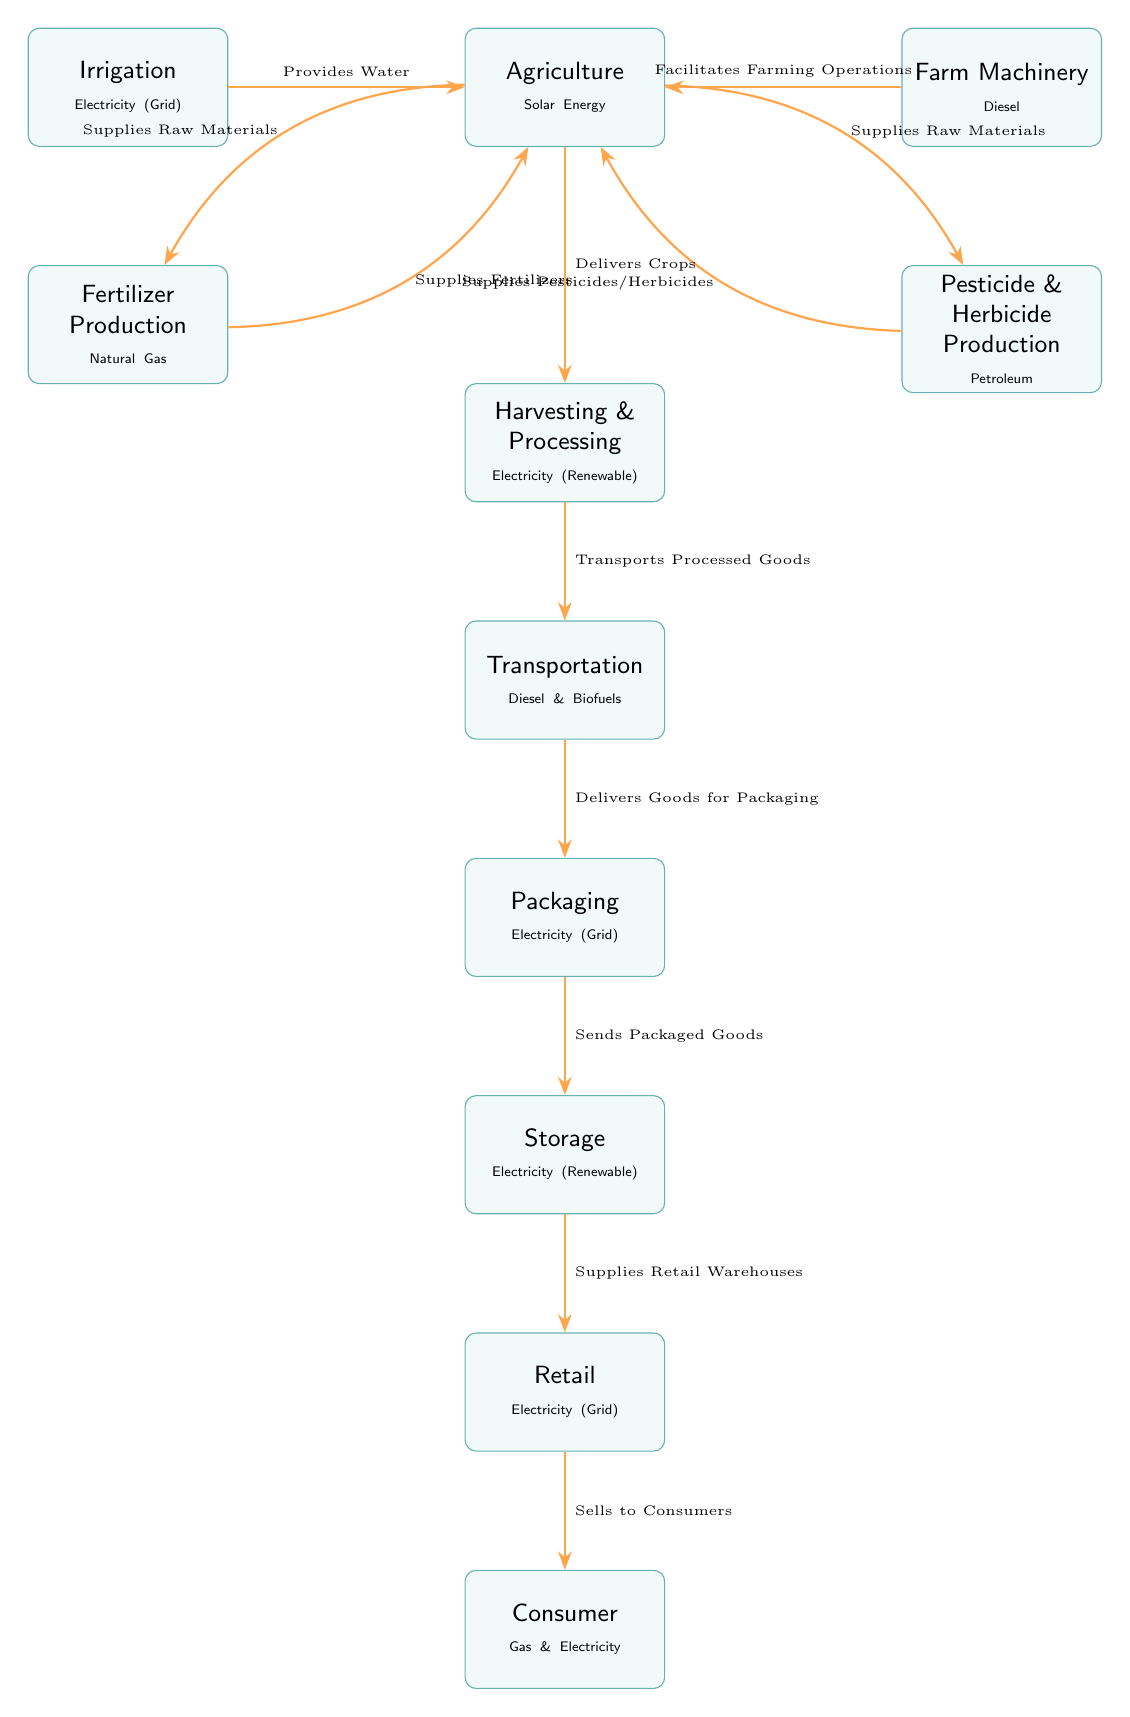What is the energy source used in agriculture? The diagram indicates that agriculture uses solar energy as its energy source, as specified in the node representing agriculture.
Answer: Solar Energy Which node produces fertilizer? The diagram clearly indicates that the fertilizer production node is linked to natural gas as its energy source, making it responsible for producing fertilizers.
Answer: Fertilizer Production What energy source is used in packaging? The diagram shows that packaging utilizes electricity from the grid, which is stated in the packaging node.
Answer: Electricity (Grid) How many nodes are in the diagram? By counting each of the distinct boxes representing different processes or stages in the food production chain, we find that there are a total of 9 nodes present in the diagram.
Answer: 9 What is supplied to agriculture from irrigation? The irrigation node is shown to provide water to agriculture, which is the input required for farming operations.
Answer: Water What is the relationship between agriculture and harvesting? The diagram illustrates that agriculture delivers crops to the harvesting process, establishing a direct flow from one node to the other as part of food production.
Answer: Delivers Crops Which two processes are powered by diesel according to the diagram? The diagram highlights that farm machinery and transportation both utilize diesel as their energy source, distinguishing them within food production.
Answer: Farm Machinery, Transportation What is the final stage before goods reach consumers? According to the flow in the diagram, the retail stage acts as the last step before products are sold to consumers, streamlining the supply chain.
Answer: Retail How is storage powered in the production process? The diagram specifies that storage relies on renewable electricity, indicating a sustainable energy source for maintaining stored goods.
Answer: Electricity (Renewable) 